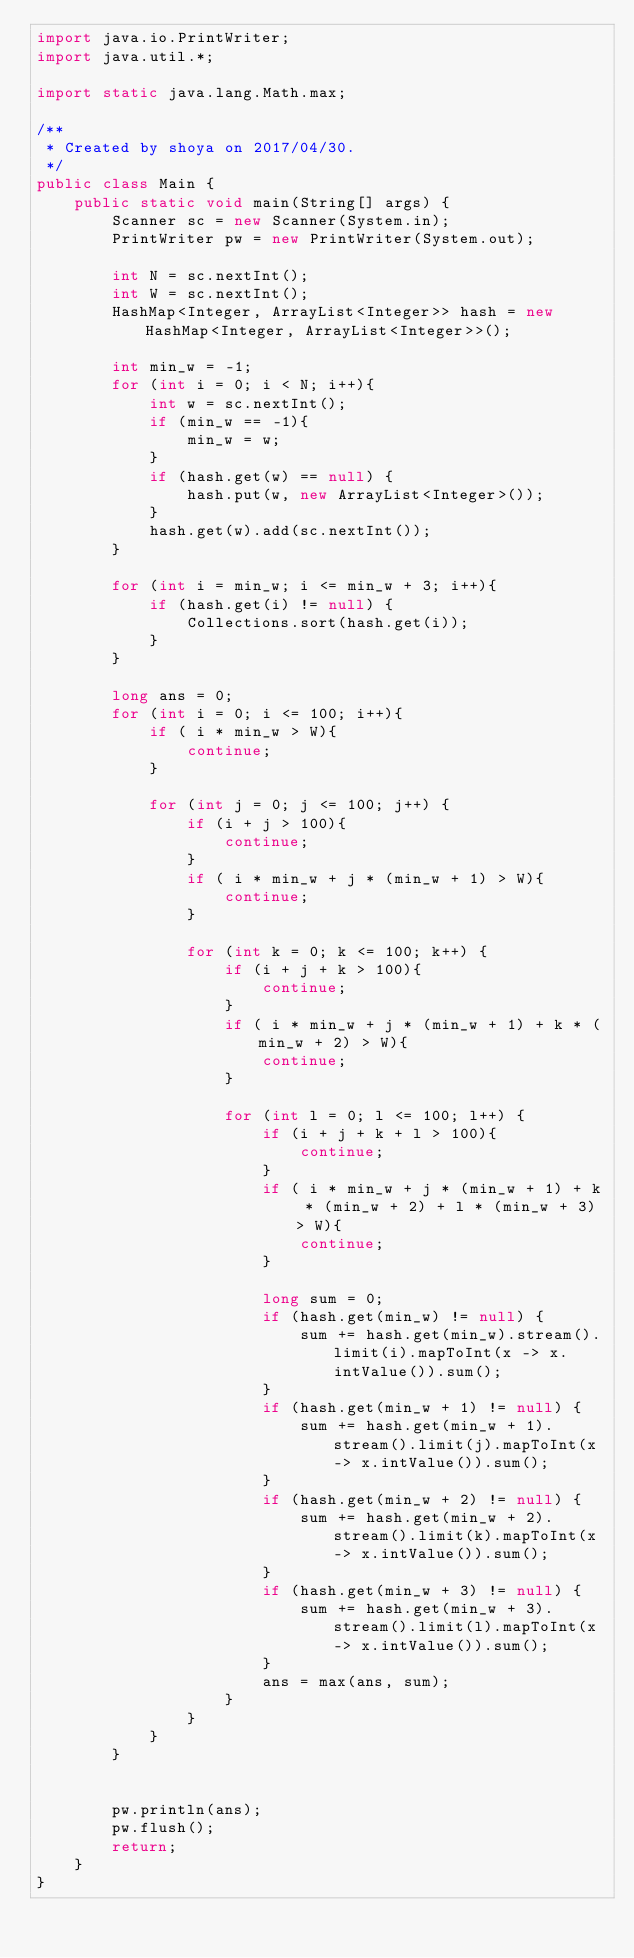Convert code to text. <code><loc_0><loc_0><loc_500><loc_500><_Java_>import java.io.PrintWriter;
import java.util.*;

import static java.lang.Math.max;

/**
 * Created by shoya on 2017/04/30.
 */
public class Main {
    public static void main(String[] args) {
        Scanner sc = new Scanner(System.in);
        PrintWriter pw = new PrintWriter(System.out);

        int N = sc.nextInt();
        int W = sc.nextInt();
        HashMap<Integer, ArrayList<Integer>> hash = new HashMap<Integer, ArrayList<Integer>>();

        int min_w = -1;
        for (int i = 0; i < N; i++){
            int w = sc.nextInt();
            if (min_w == -1){
                min_w = w;
            }
            if (hash.get(w) == null) {
                hash.put(w, new ArrayList<Integer>());
            }
            hash.get(w).add(sc.nextInt());
        }

        for (int i = min_w; i <= min_w + 3; i++){
            if (hash.get(i) != null) {
                Collections.sort(hash.get(i));
            }
        }

        long ans = 0;
        for (int i = 0; i <= 100; i++){
            if ( i * min_w > W){
                continue;
            }

            for (int j = 0; j <= 100; j++) {
                if (i + j > 100){
                    continue;
                }
                if ( i * min_w + j * (min_w + 1) > W){
                    continue;
                }

                for (int k = 0; k <= 100; k++) {
                    if (i + j + k > 100){
                        continue;
                    }
                    if ( i * min_w + j * (min_w + 1) + k * (min_w + 2) > W){
                        continue;
                    }

                    for (int l = 0; l <= 100; l++) {
                        if (i + j + k + l > 100){
                            continue;
                        }
                        if ( i * min_w + j * (min_w + 1) + k * (min_w + 2) + l * (min_w + 3) > W){
                            continue;
                        }

                        long sum = 0;
                        if (hash.get(min_w) != null) {
                            sum += hash.get(min_w).stream().limit(i).mapToInt(x -> x.intValue()).sum();
                        }
                        if (hash.get(min_w + 1) != null) {
                            sum += hash.get(min_w + 1).stream().limit(j).mapToInt(x -> x.intValue()).sum();
                        }
                        if (hash.get(min_w + 2) != null) {
                            sum += hash.get(min_w + 2).stream().limit(k).mapToInt(x -> x.intValue()).sum();
                        }
                        if (hash.get(min_w + 3) != null) {
                            sum += hash.get(min_w + 3).stream().limit(l).mapToInt(x -> x.intValue()).sum();
                        }
                        ans = max(ans, sum);
                    }
                }
            }
        }


        pw.println(ans);
        pw.flush();
        return;
    }
}</code> 